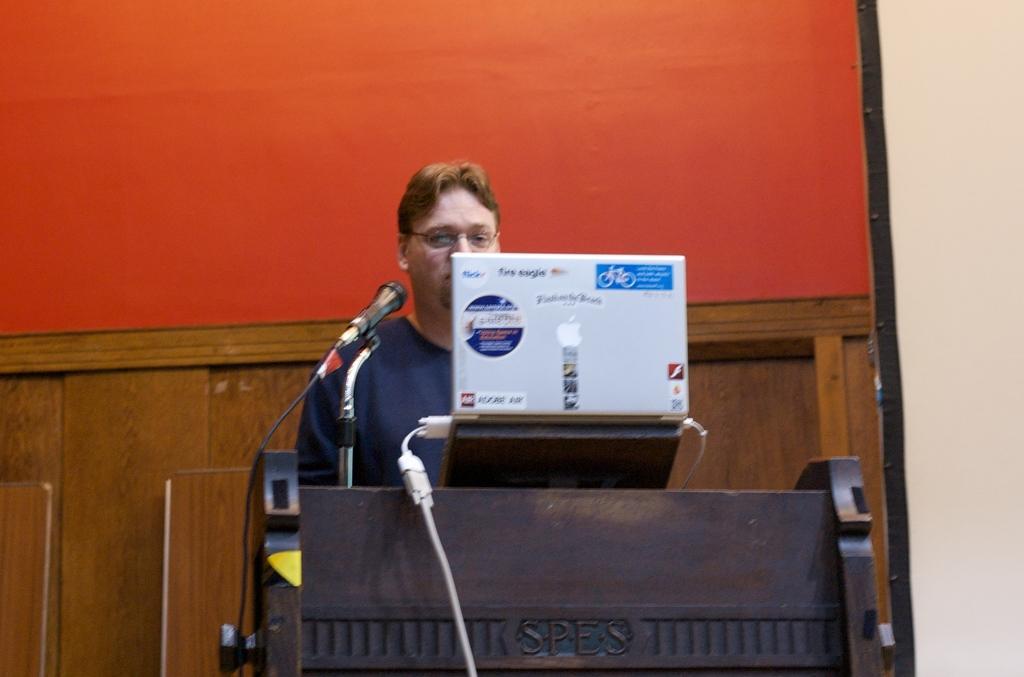Describe this image in one or two sentences. There is a laptop and a Mic kept on a table which is at the bottom of this image. We can see a man wearing black color t shirt is standing behind the laptop. We can see a wooden wall in the background. 